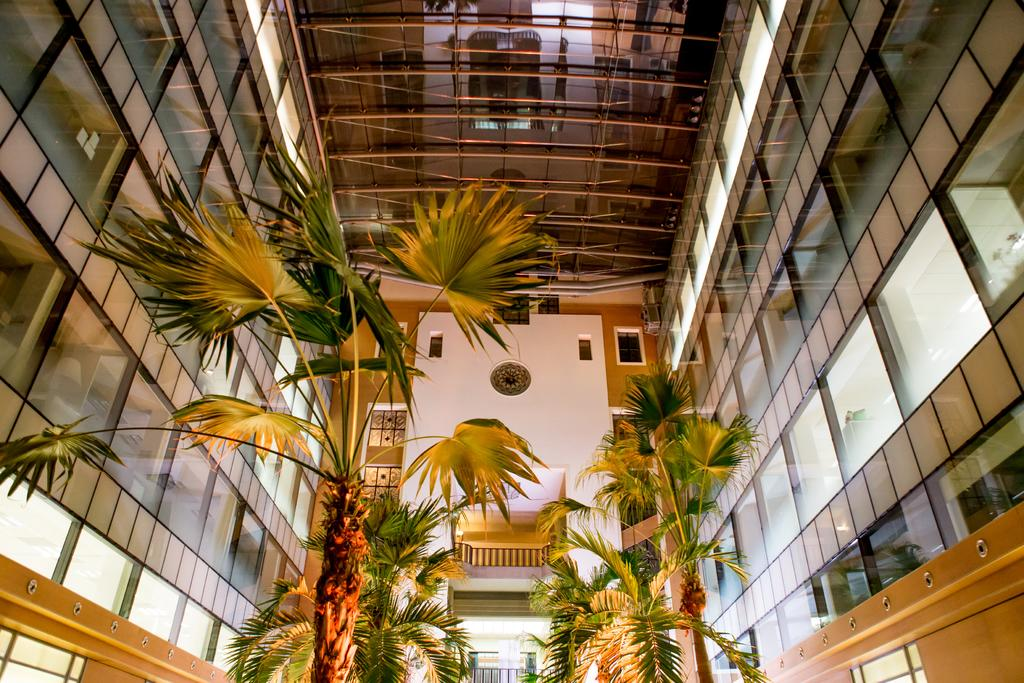What type of vegetation can be seen in the image? There are trees in the image. What type of architectural feature is present in the image? There is a glass wall in the image. What part of a building is visible at the top of the image? The roof is visible at the top of the image. Where is the balcony located in the image? The balcony is in the middle of the image. What color is the wall in the middle of the image? The wall in the middle of the image is white. Can you see any rays of light coming from the club in the image? There is no club present in the image, and therefore no rays of light from a club can be observed. Is there any visible dust on the white wall in the image? The image does not provide information about the presence of dust on the white wall, so it cannot be determined from the image. 